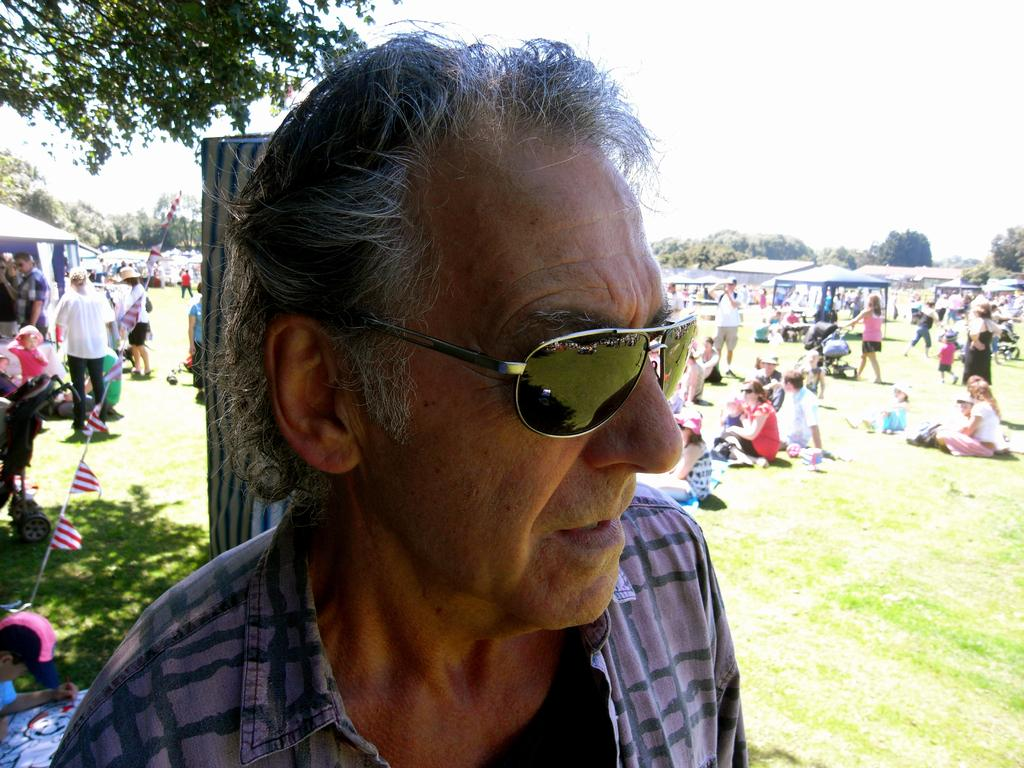What is the man in the image doing? The man is standing in front of a pole. What are the people in the image doing? The people are standing and sitting on the grass. What type of temporary shelters can be seen in the image? There are tents visible in the image. What can be seen in the background of the image? There are trees in the background of the image. What type of neck accessory is the man wearing in the image? There is no neck accessory mentioned or visible in the image. What kind of medical assistance is being provided in the image? There is no doctor or medical assistance present in the image. What type of light source is illuminating the scene in the image? There is no specific light source mentioned or visible in the image; the scene is likely illuminated by natural daylight. 